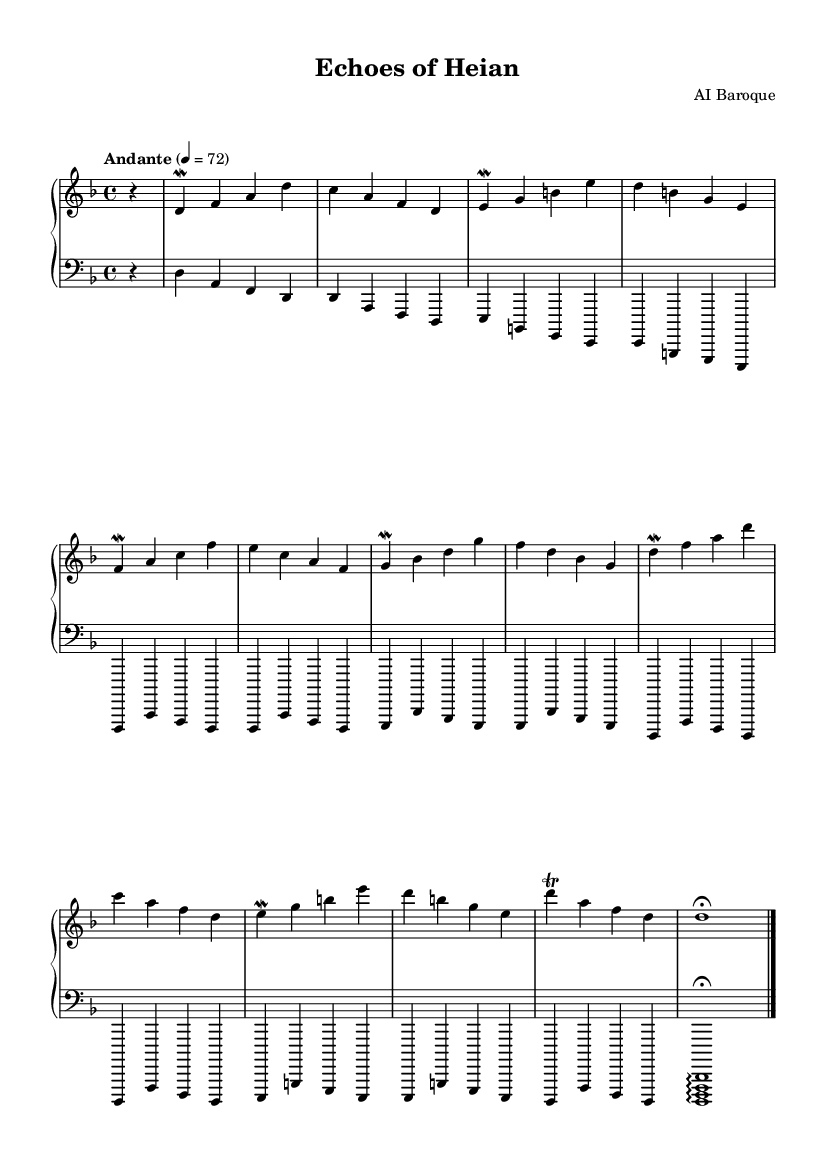What is the key signature of this music? The key signature is D minor, indicated by one flat (B flat) in the key signature section. The presence of this flat identifies the piece as belonging to the D minor scale.
Answer: D minor What is the time signature of this music? The time signature is 4/4, as shown at the beginning of the score, which indicates that there are four beats in a measure and a quarter note receives one beat.
Answer: 4/4 What is the tempo marking of this music? The tempo marking is "Andante," which indicates a moderately slow pace of the piece. The metronome marking of 72 beats per minute supports this tempo designation.
Answer: Andante How many measures are in the upper staff? There are a total of 12 measures in the upper staff, as indicated by the sequence of bar lines separating the measures throughout the section.
Answer: 12 What ornaments are used in this composition? The composition features mordents and a trill as ornaments. These are indicated by the symbols placed before the notes, such as the 'mordent' symbol and the 'trill' symbol.
Answer: mordents and trill Which instrument is primarily represented in this sheet music? The sheet music is primarily for the harpsichord, which is implied by the notation style and the context of the Baroque music era, known for utilizing this instrument significantly.
Answer: harpsichord What is the dynamic marking for the last note in the lower staff? The last note in the lower staff has a fermata marking, indicating that it should be held longer than its typical duration, suggesting a climactic ending to the piece.
Answer: fermata 